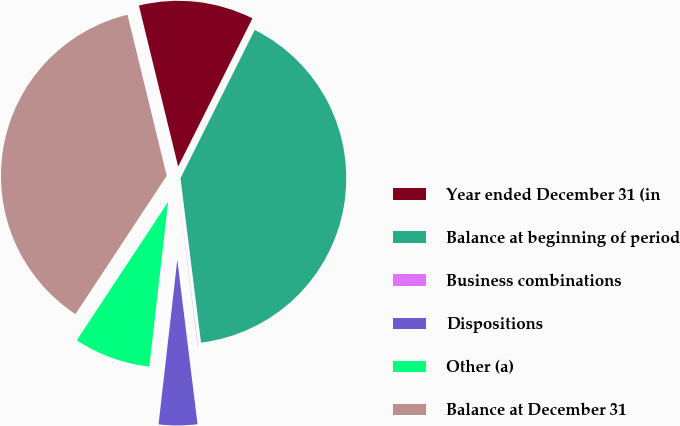Convert chart to OTSL. <chart><loc_0><loc_0><loc_500><loc_500><pie_chart><fcel>Year ended December 31 (in<fcel>Balance at beginning of period<fcel>Business combinations<fcel>Dispositions<fcel>Other (a)<fcel>Balance at December 31<nl><fcel>11.2%<fcel>40.63%<fcel>0.03%<fcel>3.75%<fcel>7.48%<fcel>36.91%<nl></chart> 